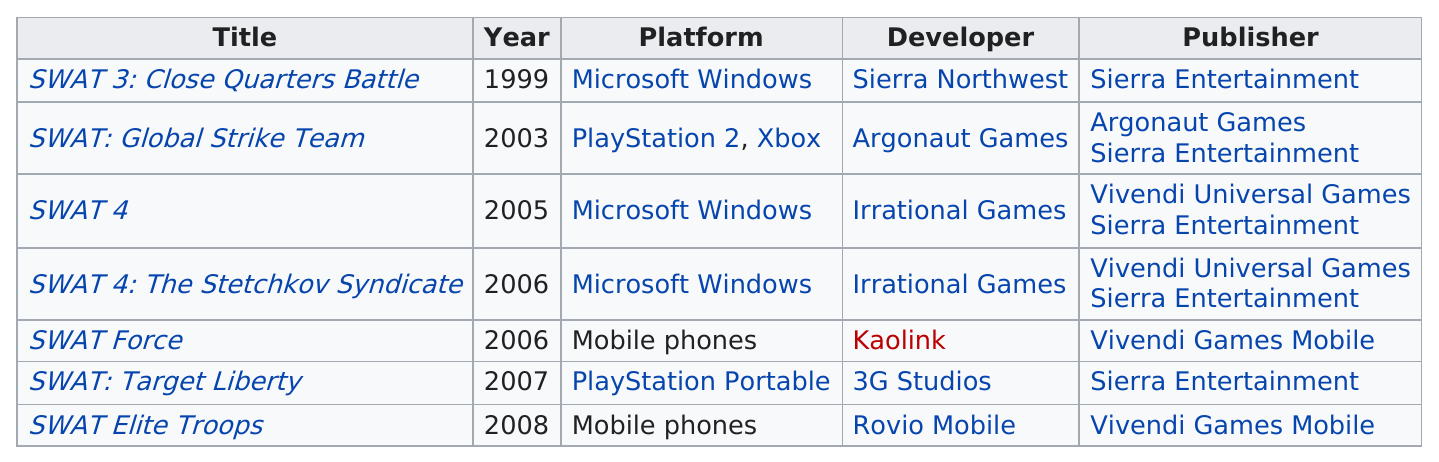Specify some key components in this picture. The number of Swat games made for Microsoft Windows is three. SWAT 4, a video game developed by the same studio as the other title SWAT 4: The Stetchkov Syndicate, shares the same developer. The titles listed below were released at least as early as 2006: "SWAT 3: Close Quarters Battle," "SWAT: Global Strike Team," "SWAT 4," "SWAT 4: The Stetchkov Syndicate," and "SWAT Force. There were three SWAT games before 2006. The total number of games in the SWAT series is 7. 